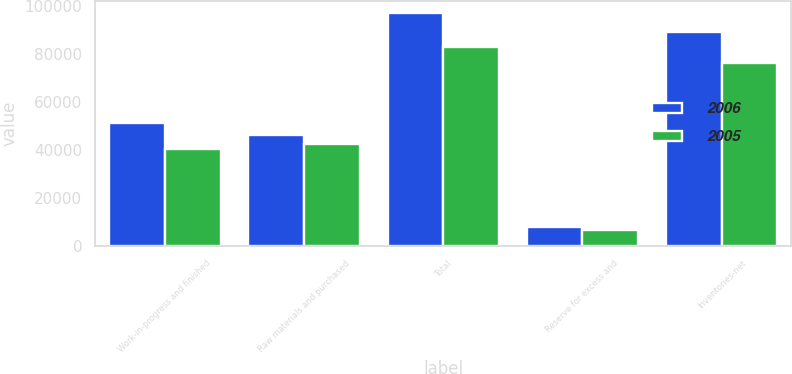<chart> <loc_0><loc_0><loc_500><loc_500><stacked_bar_chart><ecel><fcel>Work-in-progress and finished<fcel>Raw materials and purchased<fcel>Total<fcel>Reserve for excess and<fcel>Inventories-net<nl><fcel>2006<fcel>51077<fcel>46060<fcel>97137<fcel>7894<fcel>89243<nl><fcel>2005<fcel>40234<fcel>42581<fcel>82815<fcel>6738<fcel>76077<nl></chart> 